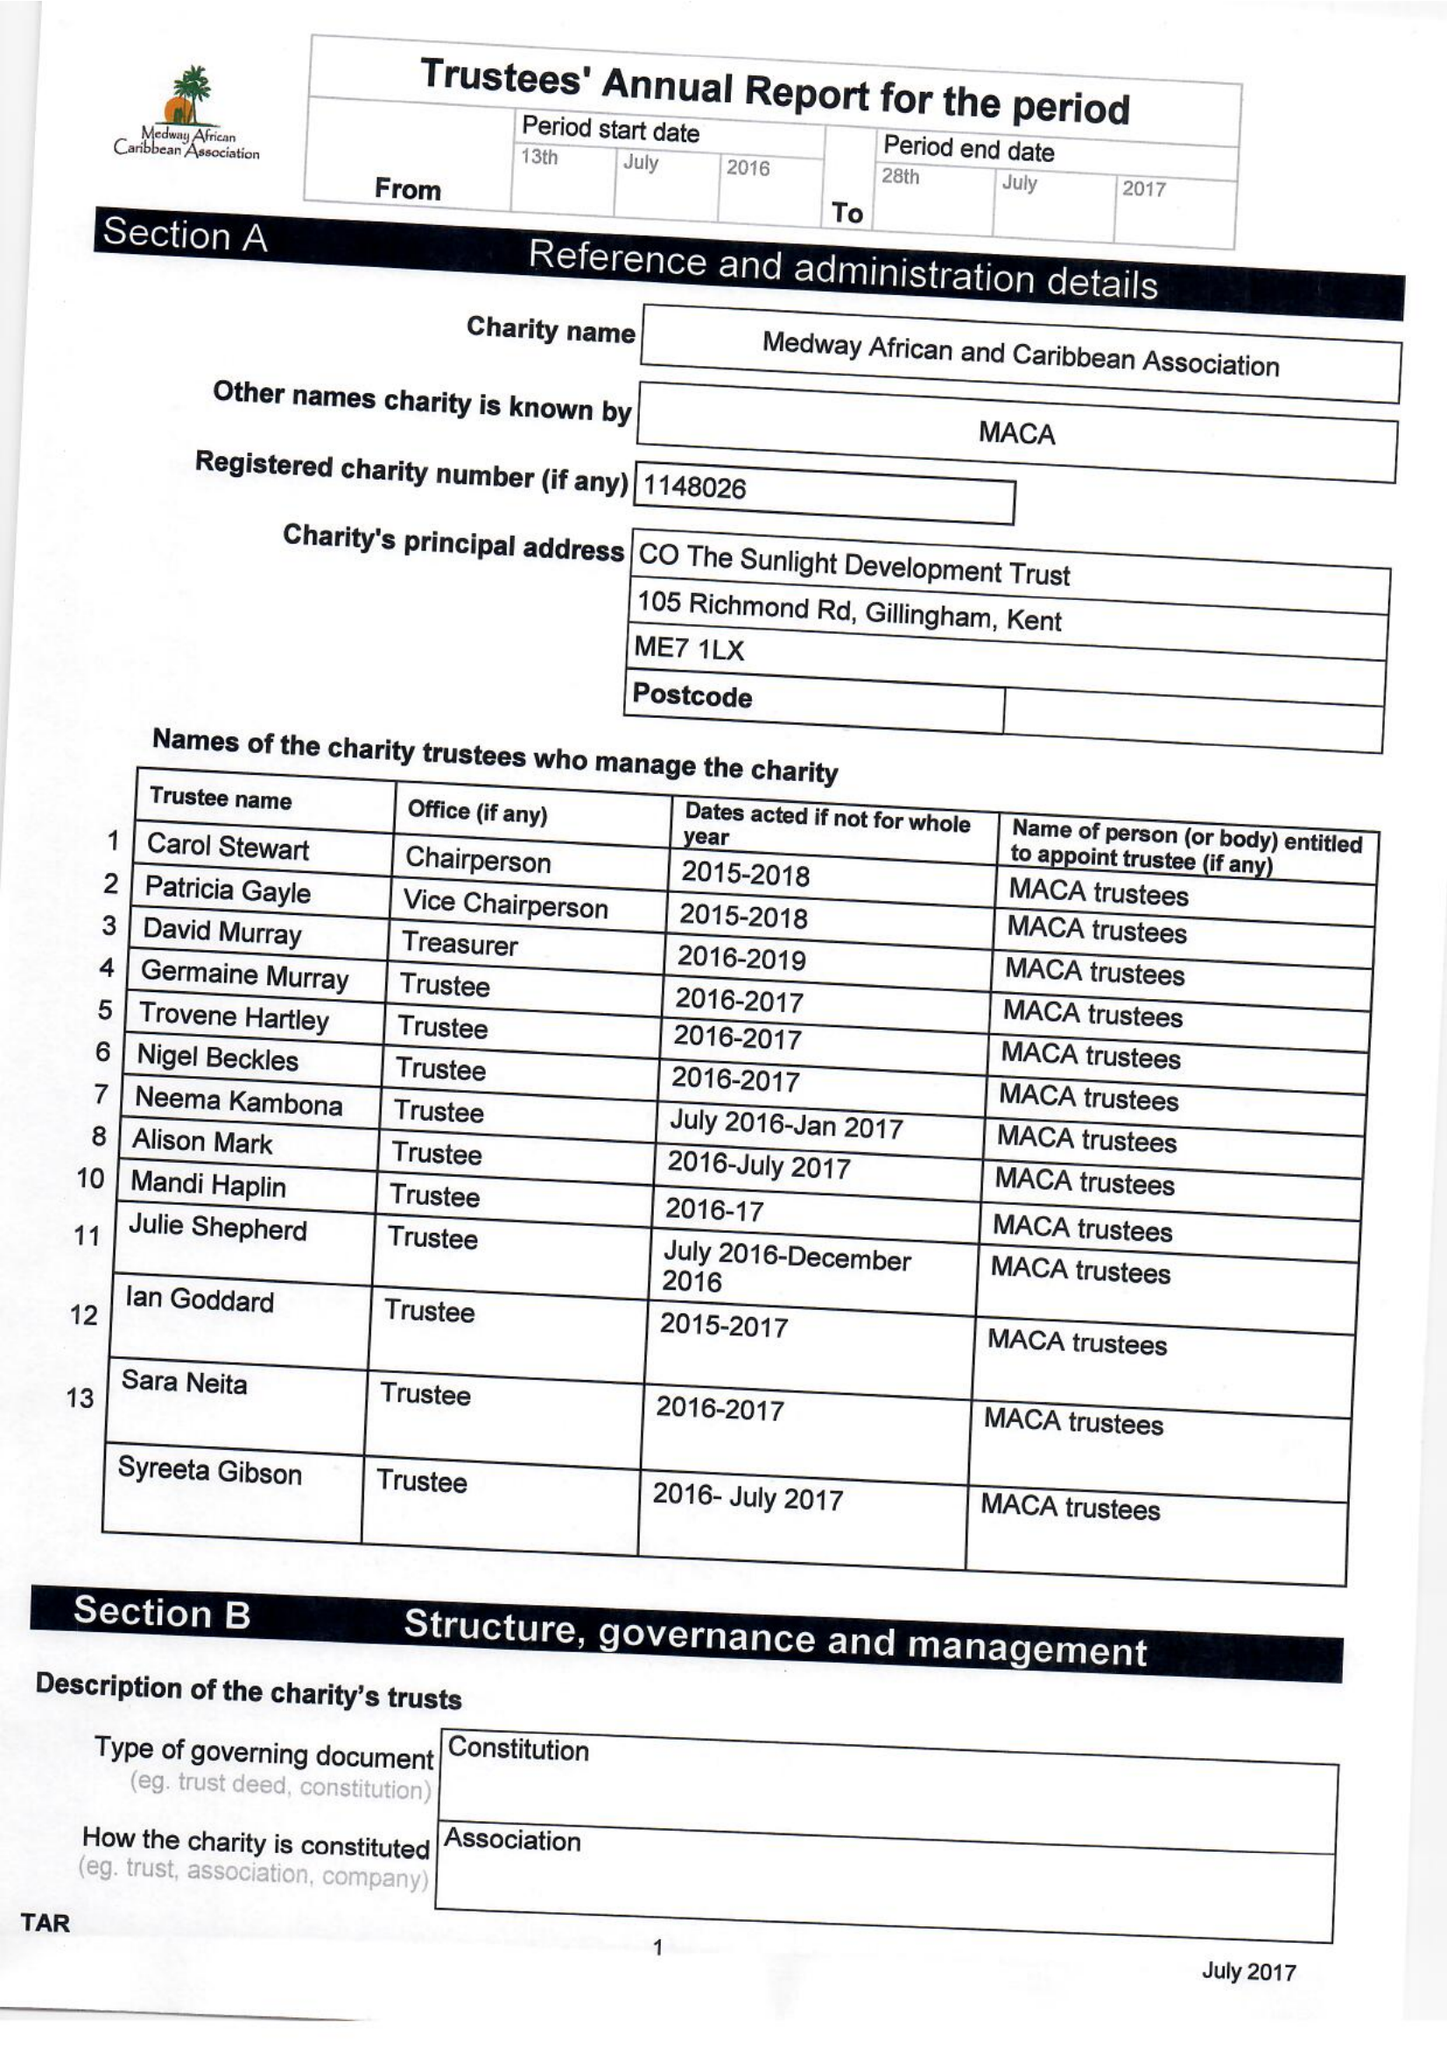What is the value for the report_date?
Answer the question using a single word or phrase. 2017-03-31 